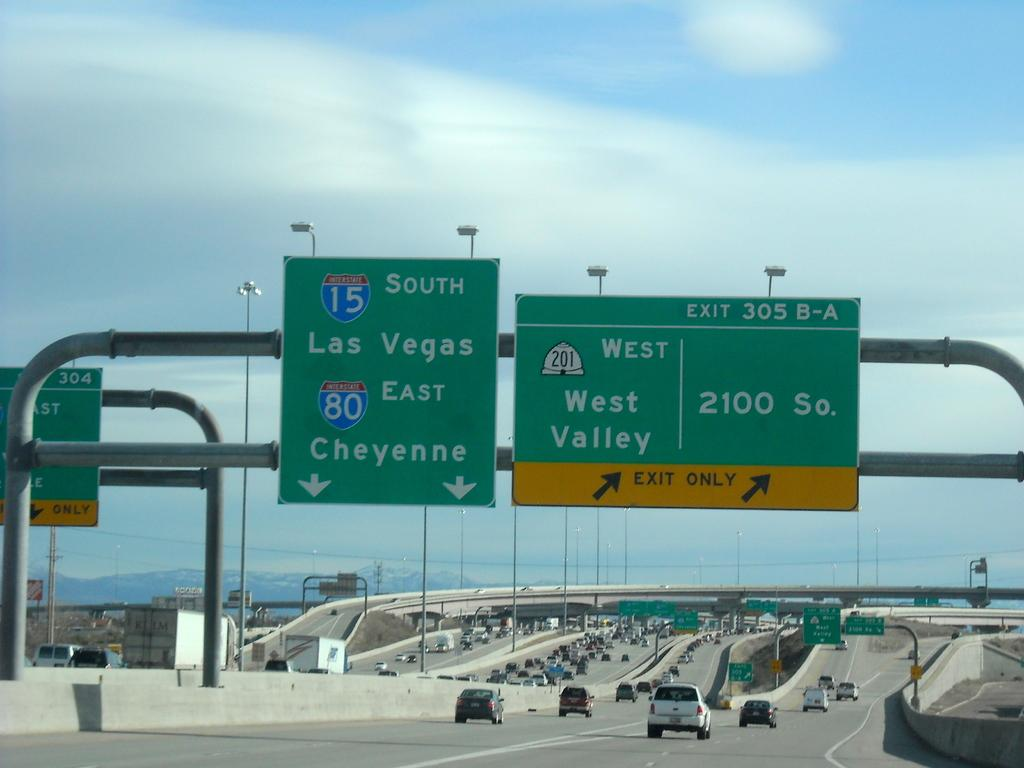<image>
Describe the image concisely. A green sign above a multi lane freeway shows that Cheyenne is up ahead. 